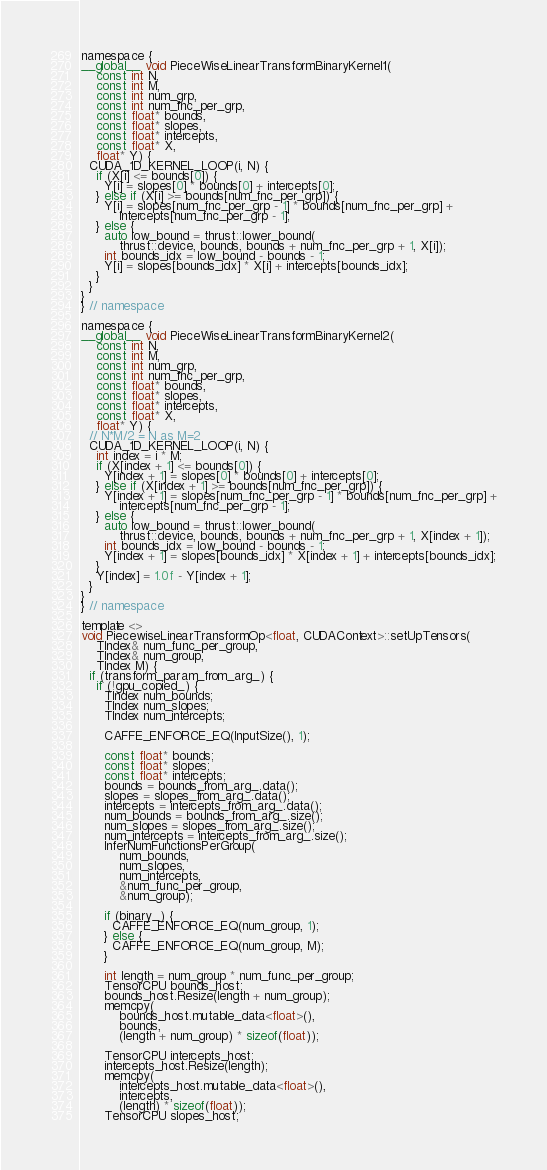<code> <loc_0><loc_0><loc_500><loc_500><_Cuda_>namespace {
__global__ void PieceWiseLinearTransformBinaryKernel1(
    const int N,
    const int M,
    const int num_grp,
    const int num_fnc_per_grp,
    const float* bounds,
    const float* slopes,
    const float* intercepts,
    const float* X,
    float* Y) {
  CUDA_1D_KERNEL_LOOP(i, N) {
    if (X[i] <= bounds[0]) {
      Y[i] = slopes[0] * bounds[0] + intercepts[0];
    } else if (X[i] >= bounds[num_fnc_per_grp]) {
      Y[i] = slopes[num_fnc_per_grp - 1] * bounds[num_fnc_per_grp] +
          intercepts[num_fnc_per_grp - 1];
    } else {
      auto low_bound = thrust::lower_bound(
          thrust::device, bounds, bounds + num_fnc_per_grp + 1, X[i]);
      int bounds_idx = low_bound - bounds - 1;
      Y[i] = slopes[bounds_idx] * X[i] + intercepts[bounds_idx];
    }
  }
}
} // namespace

namespace {
__global__ void PieceWiseLinearTransformBinaryKernel2(
    const int N,
    const int M,
    const int num_grp,
    const int num_fnc_per_grp,
    const float* bounds,
    const float* slopes,
    const float* intercepts,
    const float* X,
    float* Y) {
  // N*M/2 = N as M=2
  CUDA_1D_KERNEL_LOOP(i, N) {
    int index = i * M;
    if (X[index + 1] <= bounds[0]) {
      Y[index + 1] = slopes[0] * bounds[0] + intercepts[0];
    } else if (X[index + 1] >= bounds[num_fnc_per_grp]) {
      Y[index + 1] = slopes[num_fnc_per_grp - 1] * bounds[num_fnc_per_grp] +
          intercepts[num_fnc_per_grp - 1];
    } else {
      auto low_bound = thrust::lower_bound(
          thrust::device, bounds, bounds + num_fnc_per_grp + 1, X[index + 1]);
      int bounds_idx = low_bound - bounds - 1;
      Y[index + 1] = slopes[bounds_idx] * X[index + 1] + intercepts[bounds_idx];
    }
    Y[index] = 1.0f - Y[index + 1];
  }
}
} // namespace

template <>
void PiecewiseLinearTransformOp<float, CUDAContext>::setUpTensors(
    TIndex& num_func_per_group,
    TIndex& num_group,
    TIndex M) {
  if (transform_param_from_arg_) {
    if (!gpu_copied_) {
      TIndex num_bounds;
      TIndex num_slopes;
      TIndex num_intercepts;

      CAFFE_ENFORCE_EQ(InputSize(), 1);

      const float* bounds;
      const float* slopes;
      const float* intercepts;
      bounds = bounds_from_arg_.data();
      slopes = slopes_from_arg_.data();
      intercepts = intercepts_from_arg_.data();
      num_bounds = bounds_from_arg_.size();
      num_slopes = slopes_from_arg_.size();
      num_intercepts = intercepts_from_arg_.size();
      InferNumFunctionsPerGroup(
          num_bounds,
          num_slopes,
          num_intercepts,
          &num_func_per_group,
          &num_group);

      if (binary_) {
        CAFFE_ENFORCE_EQ(num_group, 1);
      } else {
        CAFFE_ENFORCE_EQ(num_group, M);
      }

      int length = num_group * num_func_per_group;
      TensorCPU bounds_host;
      bounds_host.Resize(length + num_group);
      memcpy(
          bounds_host.mutable_data<float>(),
          bounds,
          (length + num_group) * sizeof(float));

      TensorCPU intercepts_host;
      intercepts_host.Resize(length);
      memcpy(
          intercepts_host.mutable_data<float>(),
          intercepts,
          (length) * sizeof(float));
      TensorCPU slopes_host;</code> 